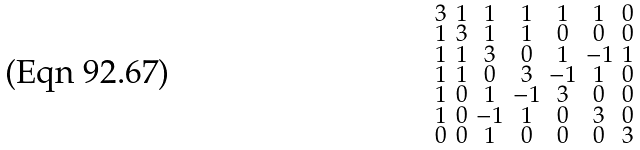Convert formula to latex. <formula><loc_0><loc_0><loc_500><loc_500>\begin{smallmatrix} 3 & 1 & 1 & 1 & 1 & 1 & 0 \\ 1 & 3 & 1 & 1 & 0 & 0 & 0 \\ 1 & 1 & 3 & 0 & 1 & - 1 & 1 \\ 1 & 1 & 0 & 3 & - 1 & 1 & 0 \\ 1 & 0 & 1 & - 1 & 3 & 0 & 0 \\ 1 & 0 & - 1 & 1 & 0 & 3 & 0 \\ 0 & 0 & 1 & 0 & 0 & 0 & 3 \end{smallmatrix}</formula> 